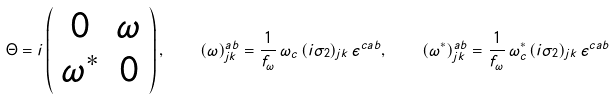Convert formula to latex. <formula><loc_0><loc_0><loc_500><loc_500>\Theta = i \left ( \begin{array} { c c } 0 & \omega \\ \omega ^ { * } & 0 \end{array} \right ) , \quad ( \omega ) ^ { a b } _ { j k } = \frac { 1 } { f _ { \omega } } \, \omega _ { c } \, ( i \sigma _ { 2 } ) _ { j k } \, \epsilon ^ { c a b } , \quad ( \omega ^ { * } ) ^ { a b } _ { j k } = \frac { 1 } { f _ { \omega } } \, \omega ^ { * } _ { c } \, ( i \sigma _ { 2 } ) _ { j k } \, \epsilon ^ { c a b }</formula> 